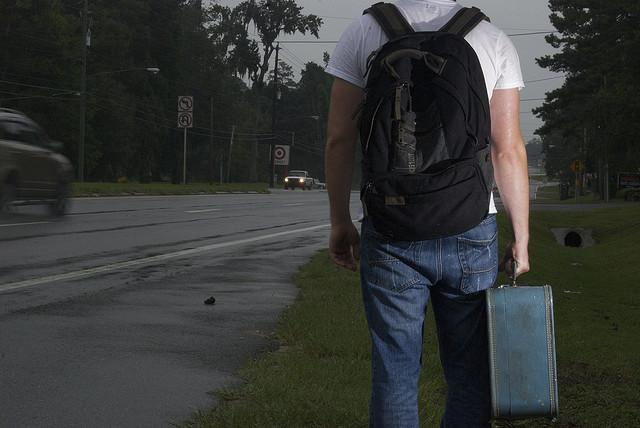What does the backpacking man hope for? Please explain your reasoning. ride. The man is walking on the side of the road with a backpack and a suitcase. the man is hitchhiking. 